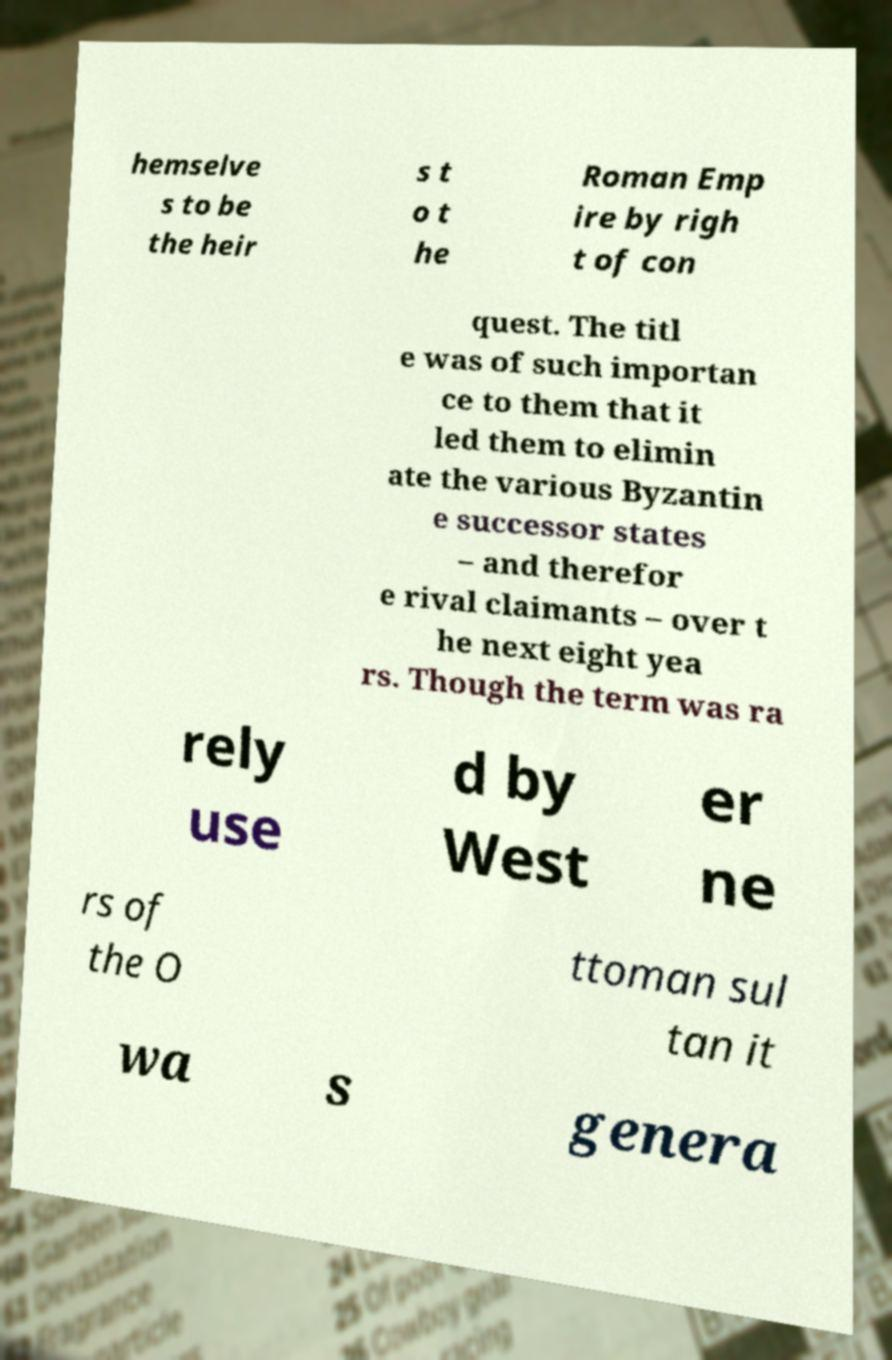What messages or text are displayed in this image? I need them in a readable, typed format. hemselve s to be the heir s t o t he Roman Emp ire by righ t of con quest. The titl e was of such importan ce to them that it led them to elimin ate the various Byzantin e successor states – and therefor e rival claimants – over t he next eight yea rs. Though the term was ra rely use d by West er ne rs of the O ttoman sul tan it wa s genera 